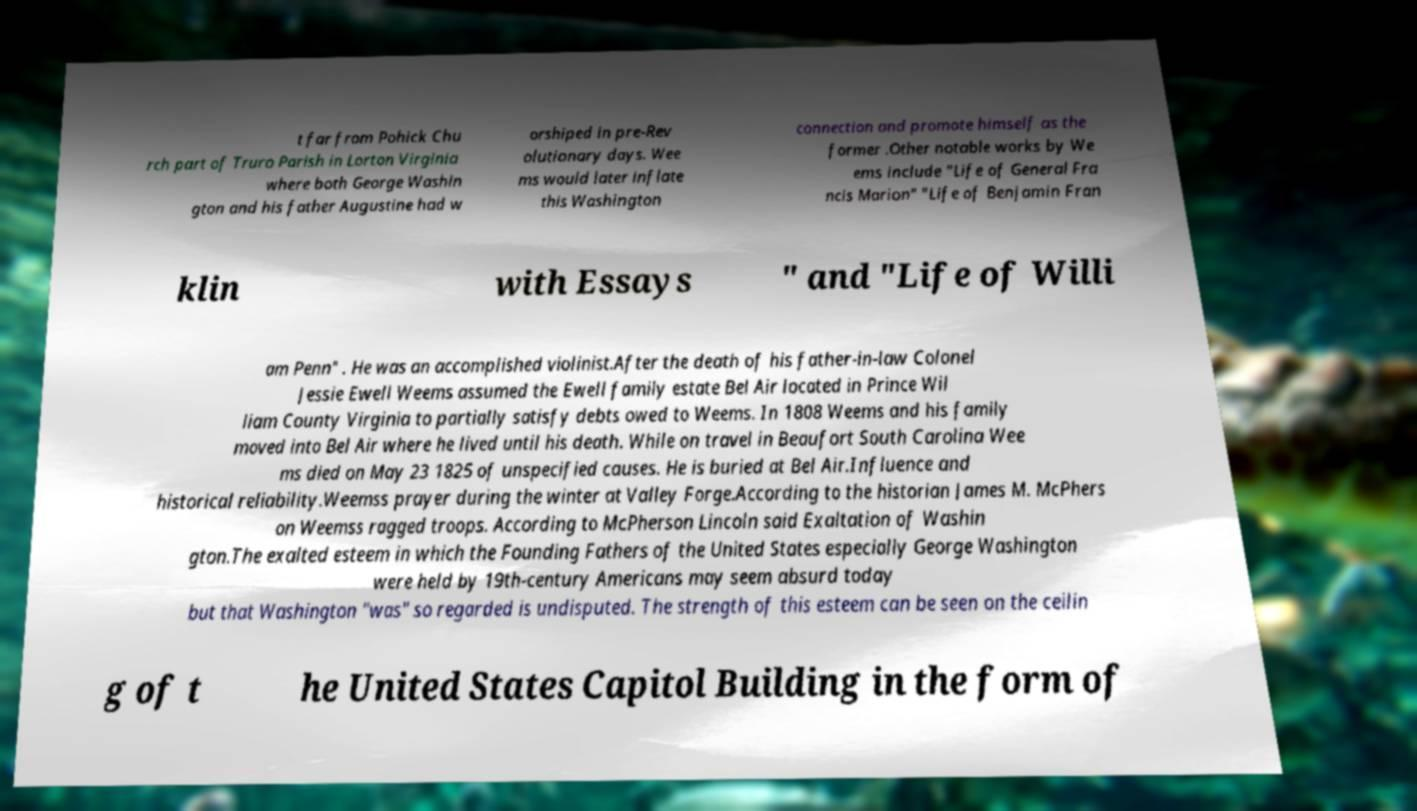Please identify and transcribe the text found in this image. t far from Pohick Chu rch part of Truro Parish in Lorton Virginia where both George Washin gton and his father Augustine had w orshiped in pre-Rev olutionary days. Wee ms would later inflate this Washington connection and promote himself as the former .Other notable works by We ems include "Life of General Fra ncis Marion" "Life of Benjamin Fran klin with Essays " and "Life of Willi am Penn" . He was an accomplished violinist.After the death of his father-in-law Colonel Jessie Ewell Weems assumed the Ewell family estate Bel Air located in Prince Wil liam County Virginia to partially satisfy debts owed to Weems. In 1808 Weems and his family moved into Bel Air where he lived until his death. While on travel in Beaufort South Carolina Wee ms died on May 23 1825 of unspecified causes. He is buried at Bel Air.Influence and historical reliability.Weemss prayer during the winter at Valley Forge.According to the historian James M. McPhers on Weemss ragged troops. According to McPherson Lincoln said Exaltation of Washin gton.The exalted esteem in which the Founding Fathers of the United States especially George Washington were held by 19th-century Americans may seem absurd today but that Washington "was" so regarded is undisputed. The strength of this esteem can be seen on the ceilin g of t he United States Capitol Building in the form of 